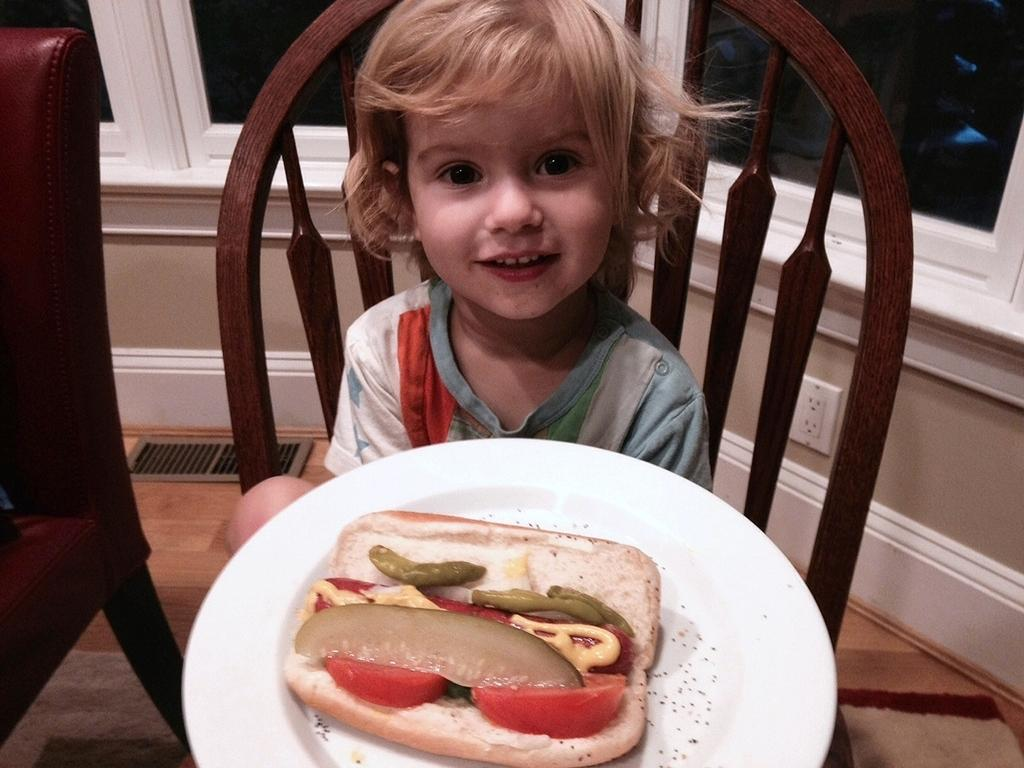What is on the plate that the kid is holding in the image? There is food in a plate in the image. What is the kid doing with the plate? The kid is holding the plate in the image. What is the kid sitting on in the image? The kid is seated on a chair in the image. What type of van can be seen parked next to the chair in the image? There is no van present in the image. What type of minister is standing behind the kid in the image? There is no minister present in the image. 